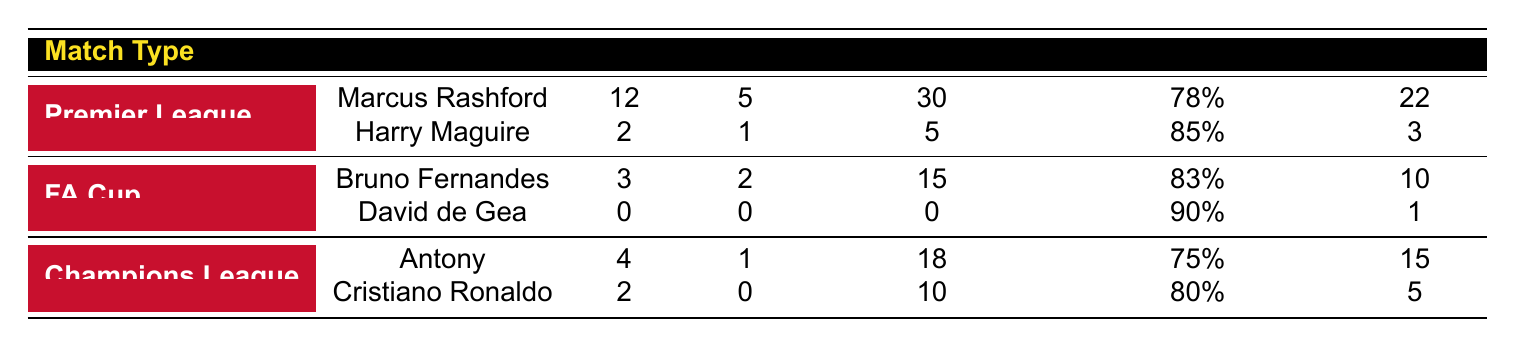What player scored the most goals in the Premier League? Marcus Rashford scored the most goals in the Premier League with a total of 12 goals, as indicated in the table.
Answer: Marcus Rashford How many assists did Bruno Fernandes have in the FA Cup? The table shows that Bruno Fernandes achieved 2 assists in the FA Cup.
Answer: 2 Which player had the highest pass completion percentage, and what was it? David de Gea had the highest pass completion percentage of 90%, as can be seen in the table under the FA Cup section.
Answer: 90% What is the total number of shots on target by players in the Champions League? To find the total, we add the shots on target from both Antony (18) and Cristiano Ronaldo (10). So, 18 + 10 = 28.
Answer: 28 Did any player score a goal in the FA Cup while David de Gea did not? Yes, Bruno Fernandes scored 3 goals in the FA Cup while David de Gea scored 0. This is evident from the table data.
Answer: Yes What is the difference in goals scored between Marcus Rashford and Harry Maguire in the Premier League? Marcus Rashford scored 12 goals, while Harry Maguire scored 2 goals. The difference is 12 - 2 = 10 goals.
Answer: 10 Which match type had the player with the most dribbles completed and how many? In the Premier League, Marcus Rashford completed 22 dribbles, which is the highest compared to all players listed in the table.
Answer: Premier League, 22 How many players scored in the Champions League? The table shows that 2 players, Antony (4 goals) and Cristiano Ronaldo (2 goals), scored in the Champions League. Therefore, the answer is 2.
Answer: 2 Which player had the fewest shots on target, and what was the number? David de Gea had 0 shots on target, indicating that he had the fewest shots on target among all players listed.
Answer: 0 